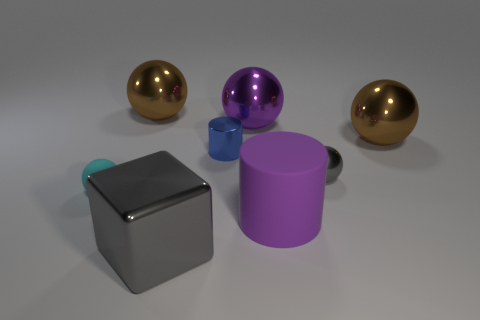Subtract 1 balls. How many balls are left? 4 Subtract all green balls. Subtract all cyan cylinders. How many balls are left? 5 Add 1 blue metallic cylinders. How many objects exist? 9 Subtract all cubes. How many objects are left? 7 Add 4 big blocks. How many big blocks are left? 5 Add 1 gray things. How many gray things exist? 3 Subtract 1 gray spheres. How many objects are left? 7 Subtract all yellow metal cubes. Subtract all small blue cylinders. How many objects are left? 7 